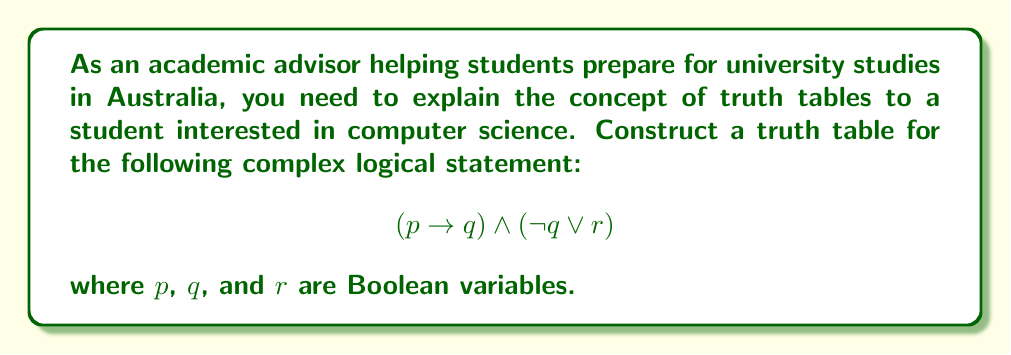Could you help me with this problem? To construct the truth table for this complex logical statement, we'll follow these steps:

1. Identify the number of variables: We have 3 variables (p, q, and r), so our truth table will have $2^3 = 8$ rows.

2. List all possible combinations of truth values for p, q, and r:
   p | q | r
   ---|---|---
   T | T | T
   T | T | F
   T | F | T
   T | F | F
   F | T | T
   F | T | F
   F | F | T
   F | F | F

3. Evaluate the sub-expressions:
   a) $p \rightarrow q$
   b) $\neg q$
   c) $\neg q \lor r$

4. Combine the results using the AND operation.

Let's evaluate each sub-expression:

a) $p \rightarrow q$:
   - True when p is false or q is true
   - False when p is true and q is false

b) $\neg q$:
   - True when q is false
   - False when q is true

c) $\neg q \lor r$:
   - True when either $\neg q$ is true or r is true
   - False when both $\neg q$ and r are false

Now, let's construct the complete truth table:

p | q | r | $p \rightarrow q$ | $\neg q$ | $\neg q \lor r$ | $(p \rightarrow q) \land (\neg q \lor r)$
---|---|---|-----------------|---------|----------------|-------------------------------------
T | T | T | T                | F       | T              | T
T | T | F | T                | F       | F              | F
T | F | T | F                | T       | T              | F
T | F | F | F                | T       | T              | F
F | T | T | T                | F       | T              | T
F | T | F | T                | F       | F              | F
F | F | T | T                | T       | T              | T
F | F | F | T                | T       | T              | T

The final column represents the result of the entire logical statement.
Answer: Truth table:
p | q | r | $(p \rightarrow q) \land (\neg q \lor r)$
---|---|---|-------------------------------------
T | T | T | T
T | T | F | F
T | F | T | F
T | F | F | F
F | T | T | T
F | T | F | F
F | F | T | T
F | F | F | T 